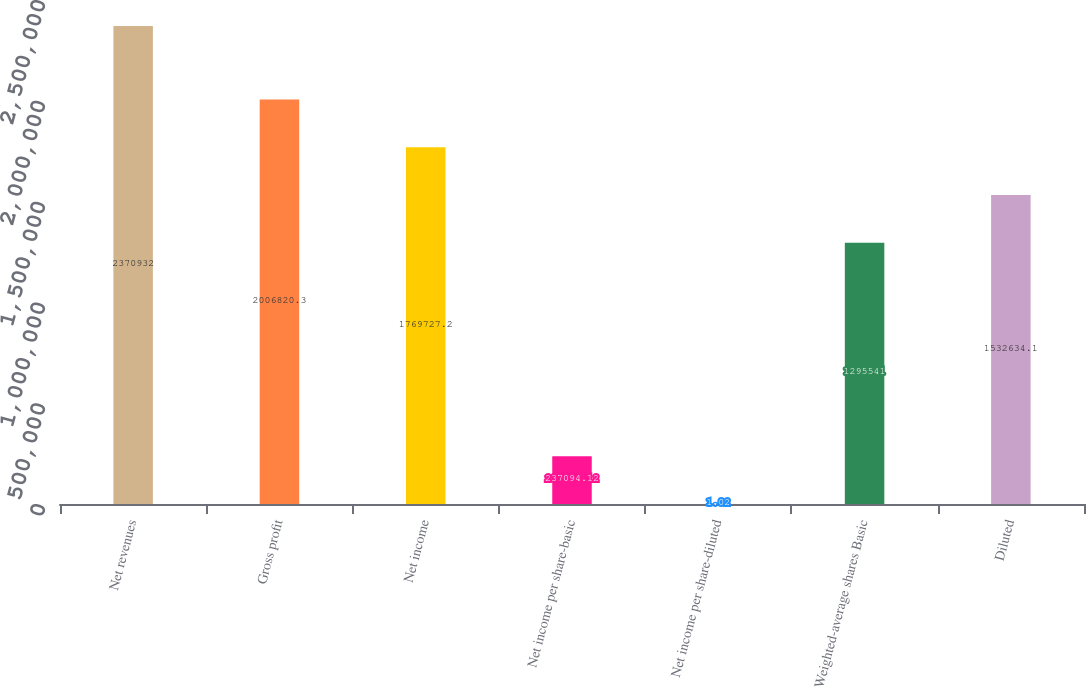Convert chart to OTSL. <chart><loc_0><loc_0><loc_500><loc_500><bar_chart><fcel>Net revenues<fcel>Gross profit<fcel>Net income<fcel>Net income per share-basic<fcel>Net income per share-diluted<fcel>Weighted-average shares Basic<fcel>Diluted<nl><fcel>2.37093e+06<fcel>2.00682e+06<fcel>1.76973e+06<fcel>237094<fcel>1.02<fcel>1.29554e+06<fcel>1.53263e+06<nl></chart> 